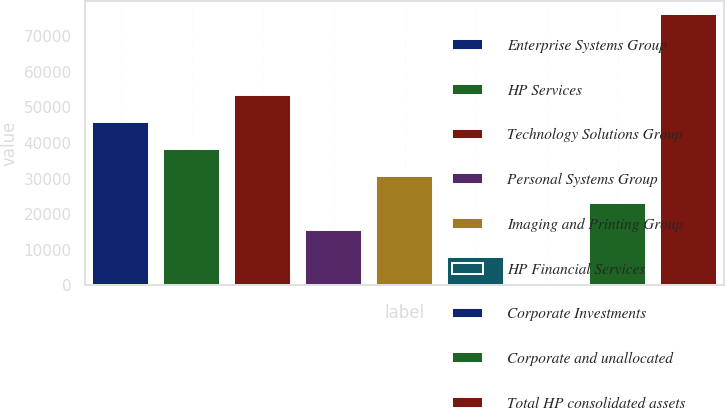Convert chart. <chart><loc_0><loc_0><loc_500><loc_500><bar_chart><fcel>Enterprise Systems Group<fcel>HP Services<fcel>Technology Solutions Group<fcel>Personal Systems Group<fcel>Imaging and Printing Group<fcel>HP Financial Services<fcel>Corporate Investments<fcel>Corporate and unallocated<fcel>Total HP consolidated assets<nl><fcel>45873.5<fcel>38297.2<fcel>53449.8<fcel>15568.3<fcel>30720.9<fcel>7992<fcel>375<fcel>23144.6<fcel>76138<nl></chart> 